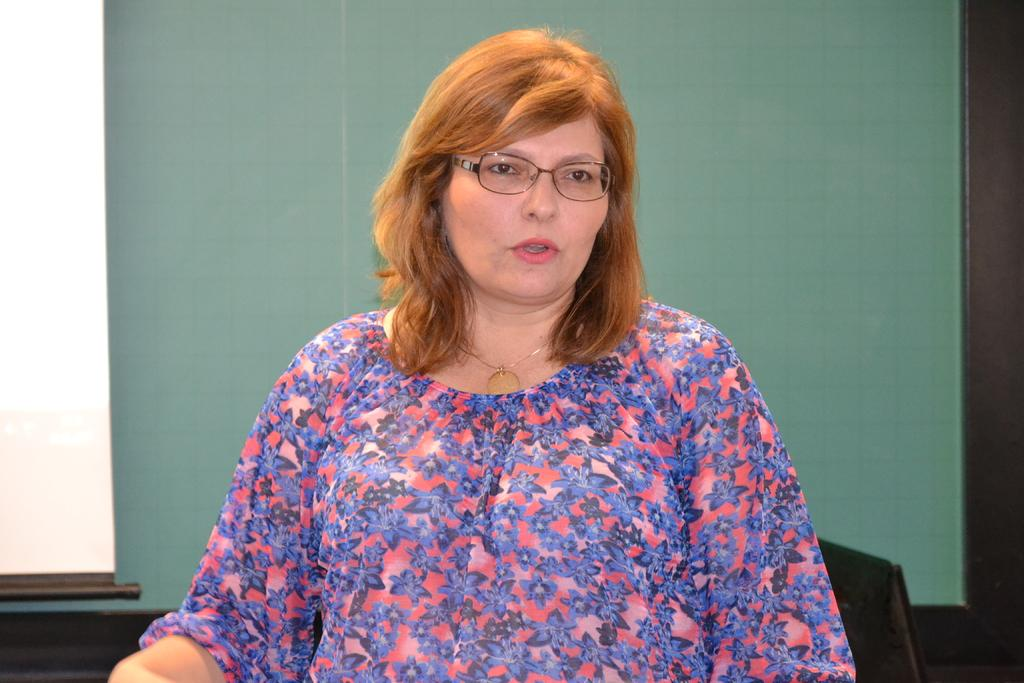Who is present in the image? There is a woman in the image. What accessory is the woman wearing? The woman is wearing spectacles. What can be seen in the background of the image? There is a board visible in the background of the image. What type of insect can be seen flying around the woman's head in the image? There is no insect present in the image; it only features a woman and a board in the background. 